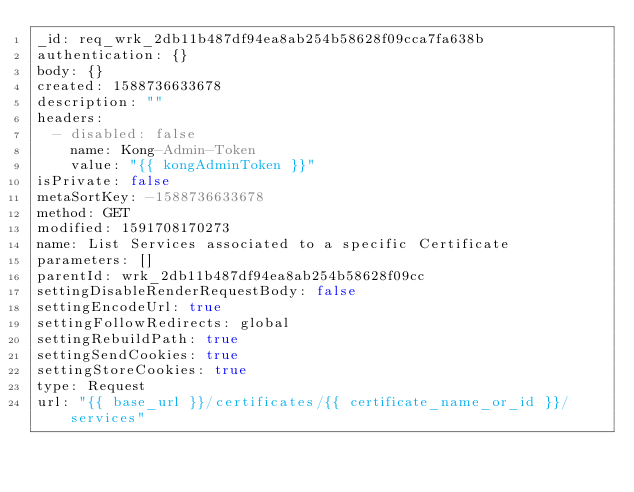<code> <loc_0><loc_0><loc_500><loc_500><_YAML_>_id: req_wrk_2db11b487df94ea8ab254b58628f09cca7fa638b
authentication: {}
body: {}
created: 1588736633678
description: ""
headers:
  - disabled: false
    name: Kong-Admin-Token
    value: "{{ kongAdminToken }}"
isPrivate: false
metaSortKey: -1588736633678
method: GET
modified: 1591708170273
name: List Services associated to a specific Certificate
parameters: []
parentId: wrk_2db11b487df94ea8ab254b58628f09cc
settingDisableRenderRequestBody: false
settingEncodeUrl: true
settingFollowRedirects: global
settingRebuildPath: true
settingSendCookies: true
settingStoreCookies: true
type: Request
url: "{{ base_url }}/certificates/{{ certificate_name_or_id }}/services"
</code> 